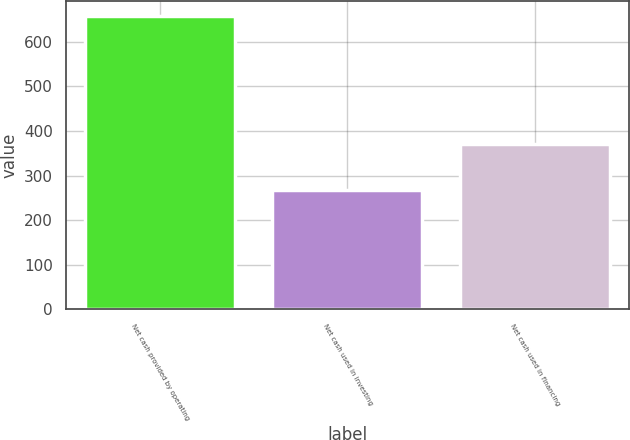Convert chart. <chart><loc_0><loc_0><loc_500><loc_500><bar_chart><fcel>Net cash provided by operating<fcel>Net cash used in investing<fcel>Net cash used in financing<nl><fcel>658.1<fcel>267.1<fcel>371.5<nl></chart> 